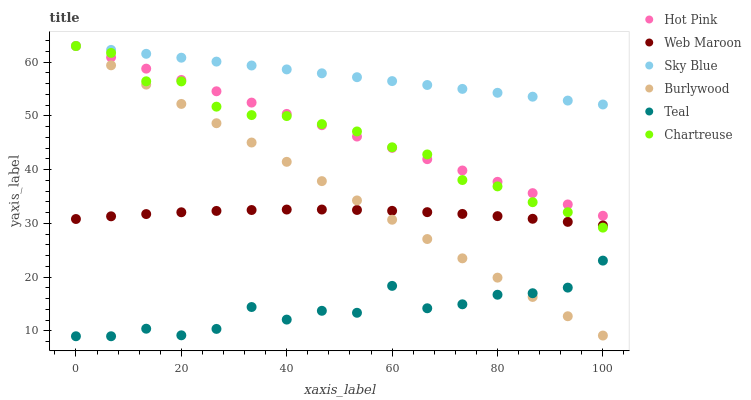Does Teal have the minimum area under the curve?
Answer yes or no. Yes. Does Sky Blue have the maximum area under the curve?
Answer yes or no. Yes. Does Hot Pink have the minimum area under the curve?
Answer yes or no. No. Does Hot Pink have the maximum area under the curve?
Answer yes or no. No. Is Sky Blue the smoothest?
Answer yes or no. Yes. Is Teal the roughest?
Answer yes or no. Yes. Is Hot Pink the smoothest?
Answer yes or no. No. Is Hot Pink the roughest?
Answer yes or no. No. Does Teal have the lowest value?
Answer yes or no. Yes. Does Hot Pink have the lowest value?
Answer yes or no. No. Does Sky Blue have the highest value?
Answer yes or no. Yes. Does Web Maroon have the highest value?
Answer yes or no. No. Is Teal less than Sky Blue?
Answer yes or no. Yes. Is Sky Blue greater than Teal?
Answer yes or no. Yes. Does Sky Blue intersect Chartreuse?
Answer yes or no. Yes. Is Sky Blue less than Chartreuse?
Answer yes or no. No. Is Sky Blue greater than Chartreuse?
Answer yes or no. No. Does Teal intersect Sky Blue?
Answer yes or no. No. 